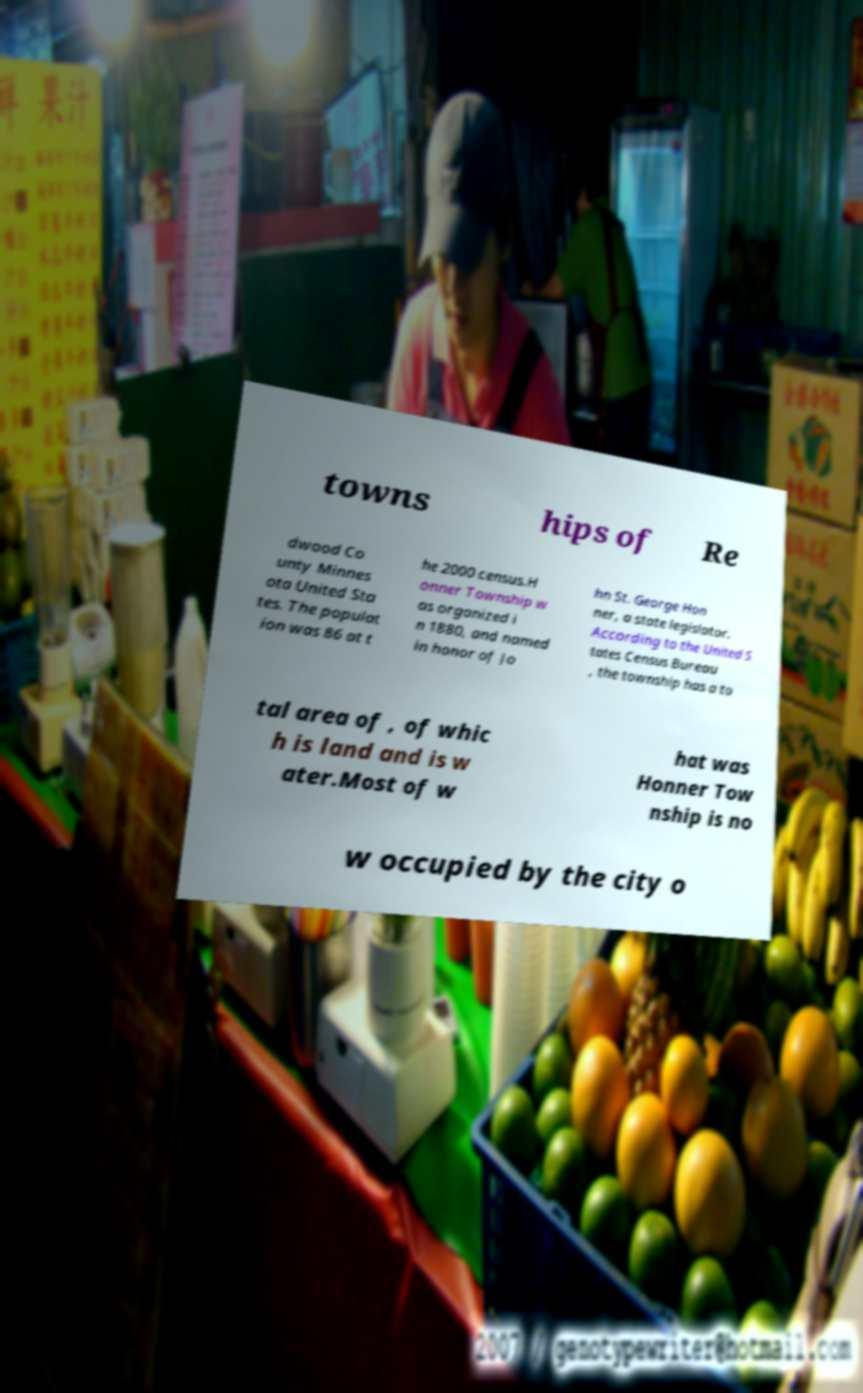For documentation purposes, I need the text within this image transcribed. Could you provide that? towns hips of Re dwood Co unty Minnes ota United Sta tes. The populat ion was 86 at t he 2000 census.H onner Township w as organized i n 1880, and named in honor of Jo hn St. George Hon ner, a state legislator. According to the United S tates Census Bureau , the township has a to tal area of , of whic h is land and is w ater.Most of w hat was Honner Tow nship is no w occupied by the city o 